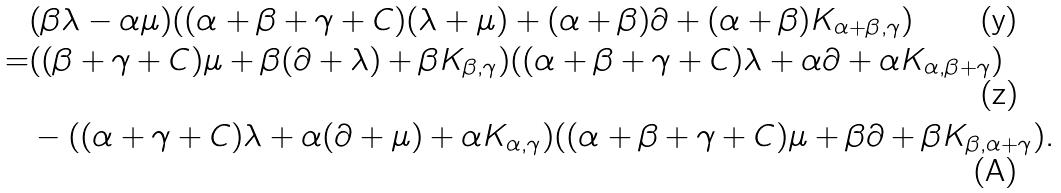Convert formula to latex. <formula><loc_0><loc_0><loc_500><loc_500>& ( \beta \lambda - \alpha \mu ) ( ( \alpha + \beta + \gamma + C ) ( \lambda + \mu ) + ( \alpha + \beta ) \partial + ( \alpha + \beta ) K _ { \alpha + \beta , \gamma } ) \\ = & ( ( \beta + \gamma + C ) \mu + \beta ( \partial + \lambda ) + \beta K _ { \beta , \gamma } ) ( ( \alpha + \beta + \gamma + C ) \lambda + \alpha \partial + \alpha K _ { \alpha , \beta + \gamma } ) \\ & - ( ( \alpha + \gamma + C ) \lambda + \alpha ( \partial + \mu ) + \alpha K _ { \alpha , \gamma } ) ( ( \alpha + \beta + \gamma + C ) \mu + \beta \partial + \beta K _ { \beta , \alpha + \gamma } ) .</formula> 